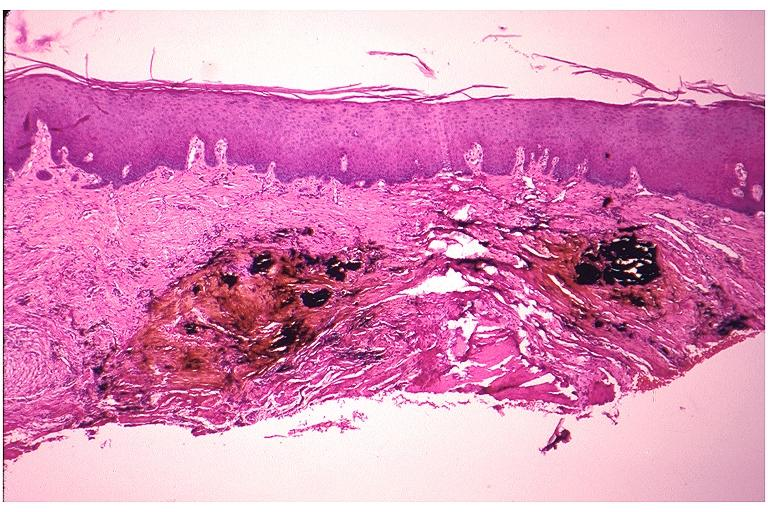what is present?
Answer the question using a single word or phrase. Oral 